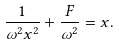<formula> <loc_0><loc_0><loc_500><loc_500>\frac { 1 } { \omega ^ { 2 } x ^ { 2 } } + \frac { F } { \omega ^ { 2 } } = x .</formula> 